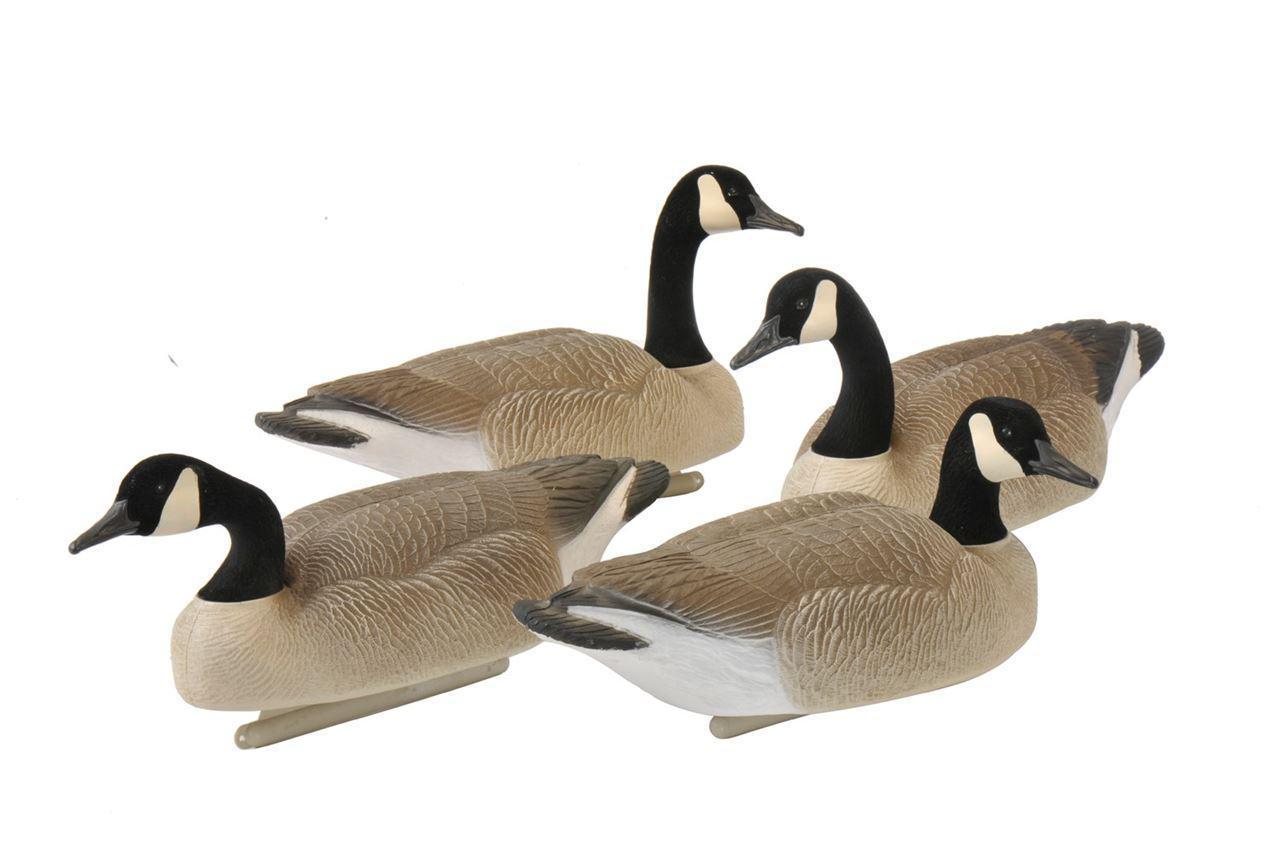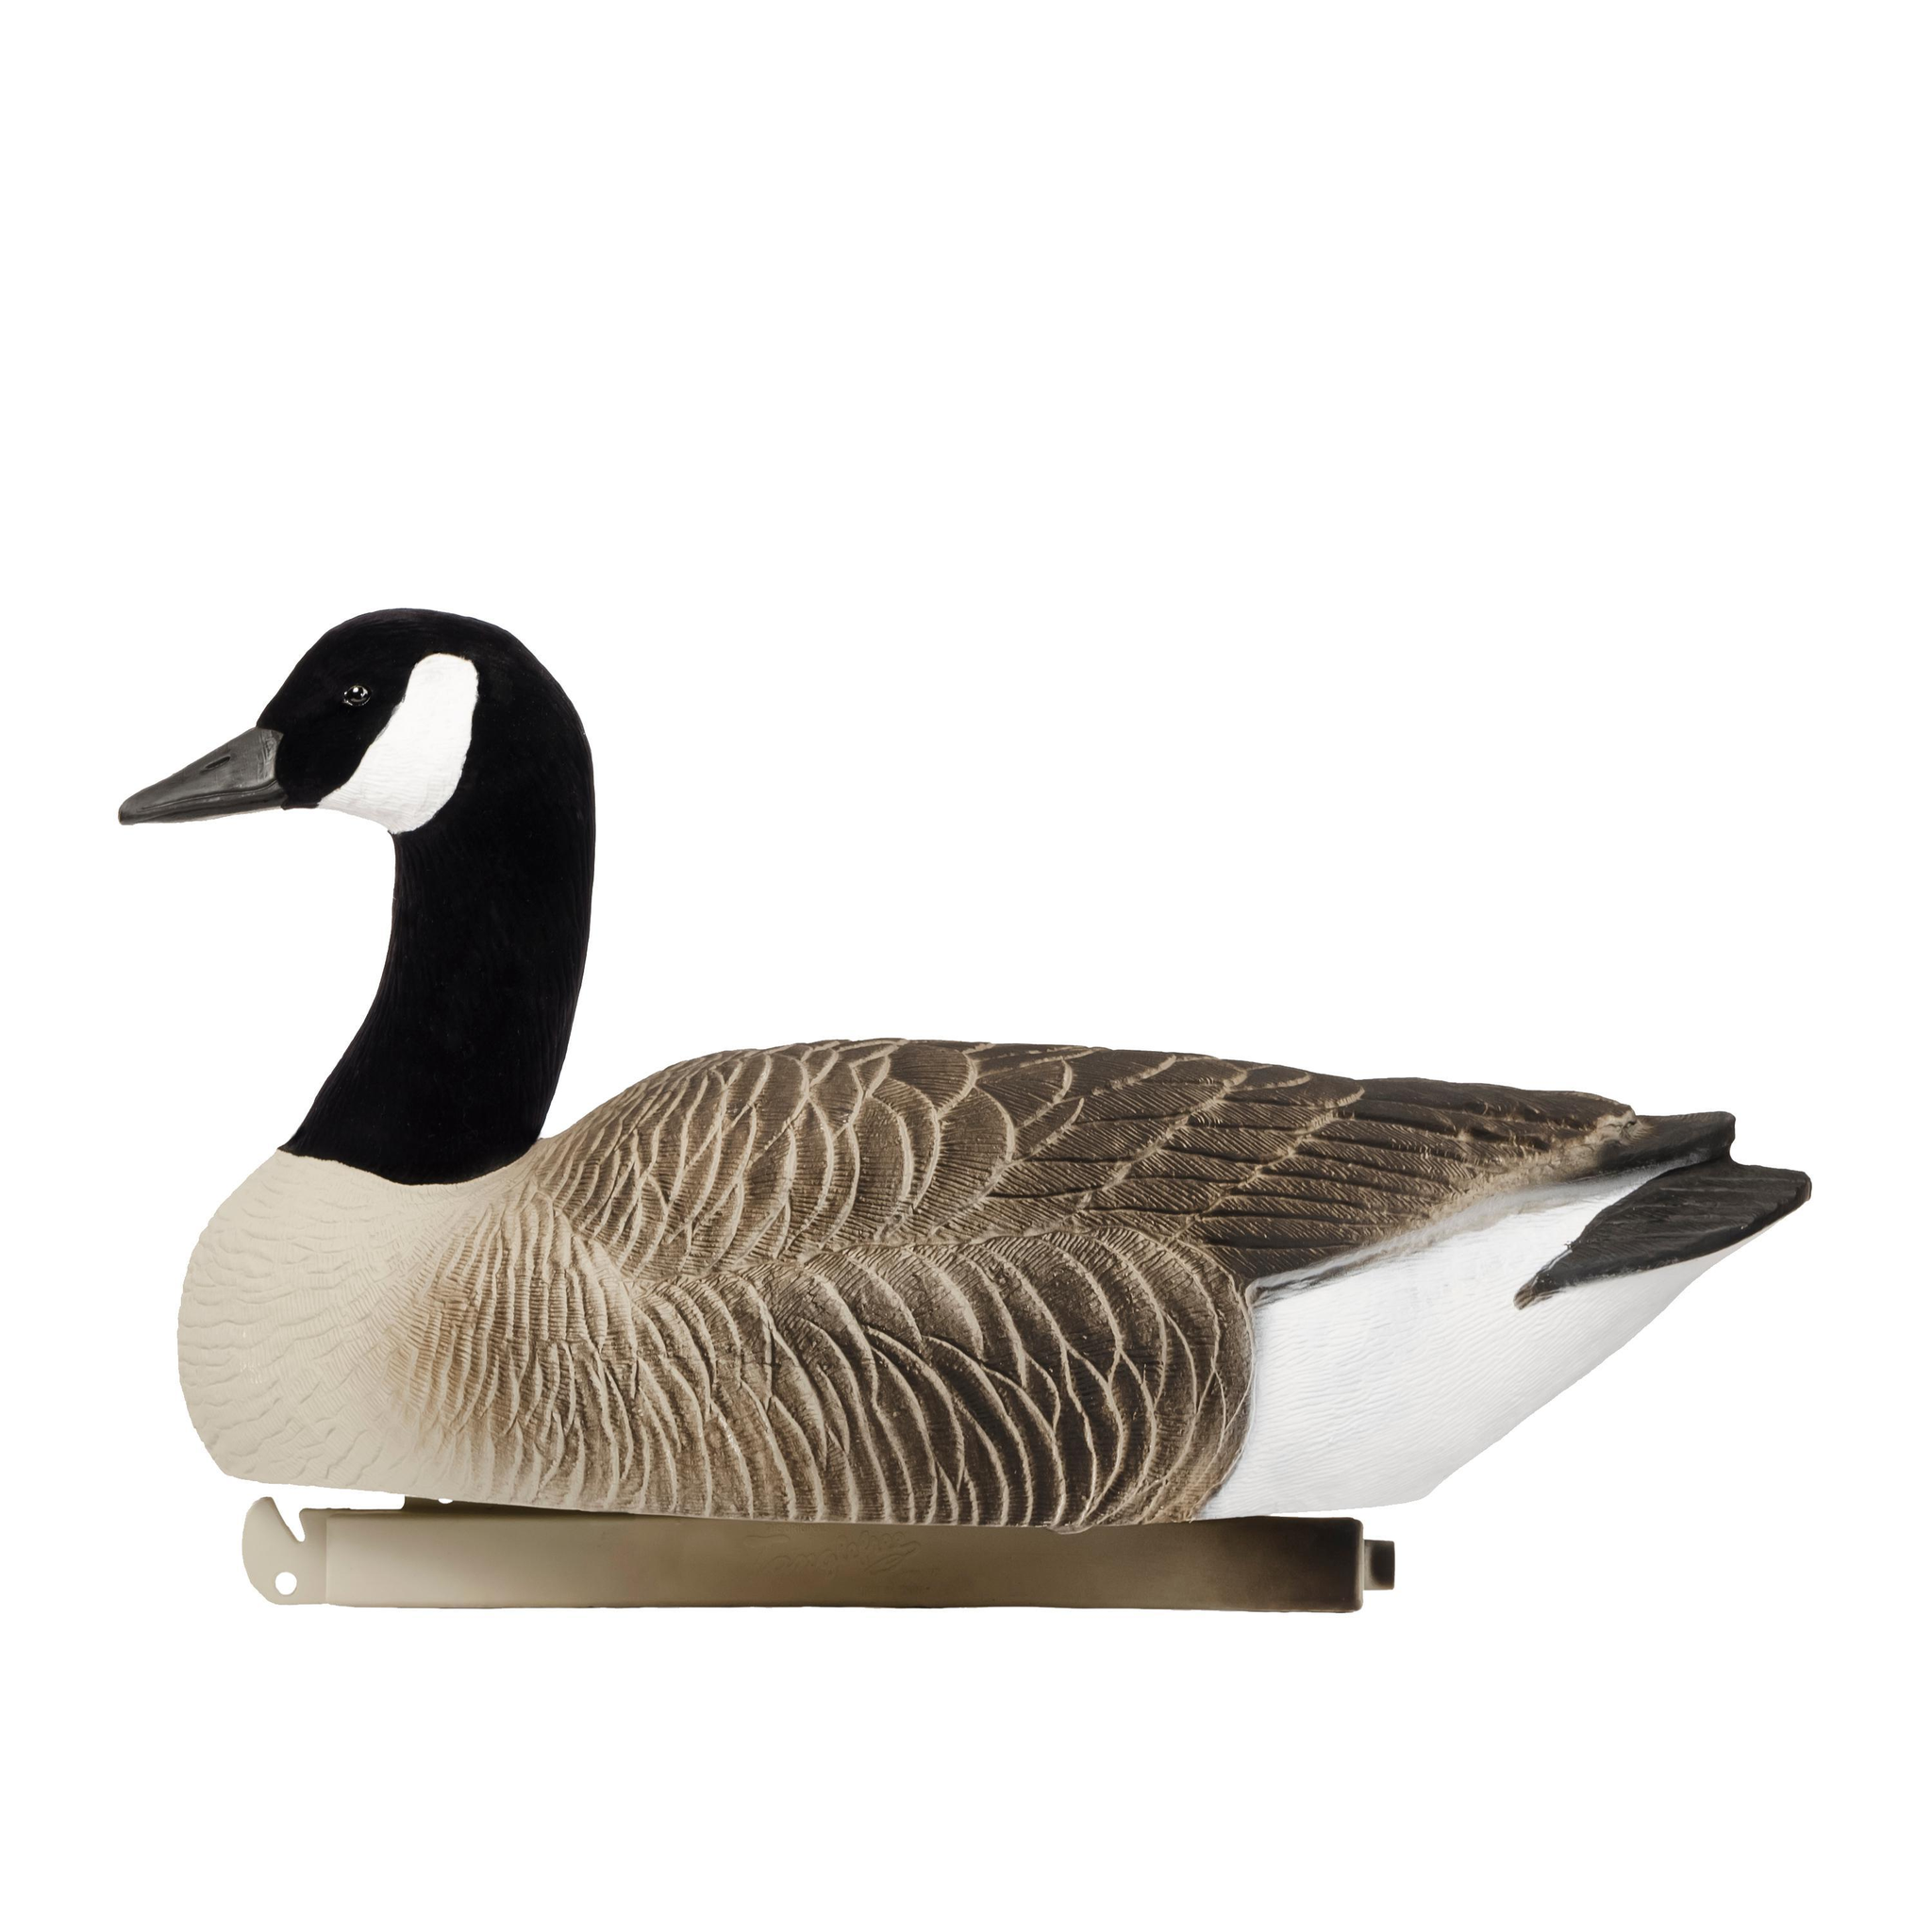The first image is the image on the left, the second image is the image on the right. Evaluate the accuracy of this statement regarding the images: "All decoy birds have black necks, and one image contains at least four decoy birds, while the other image contains just one.". Is it true? Answer yes or no. Yes. The first image is the image on the left, the second image is the image on the right. For the images shown, is this caption "There are five duck decoys." true? Answer yes or no. Yes. 